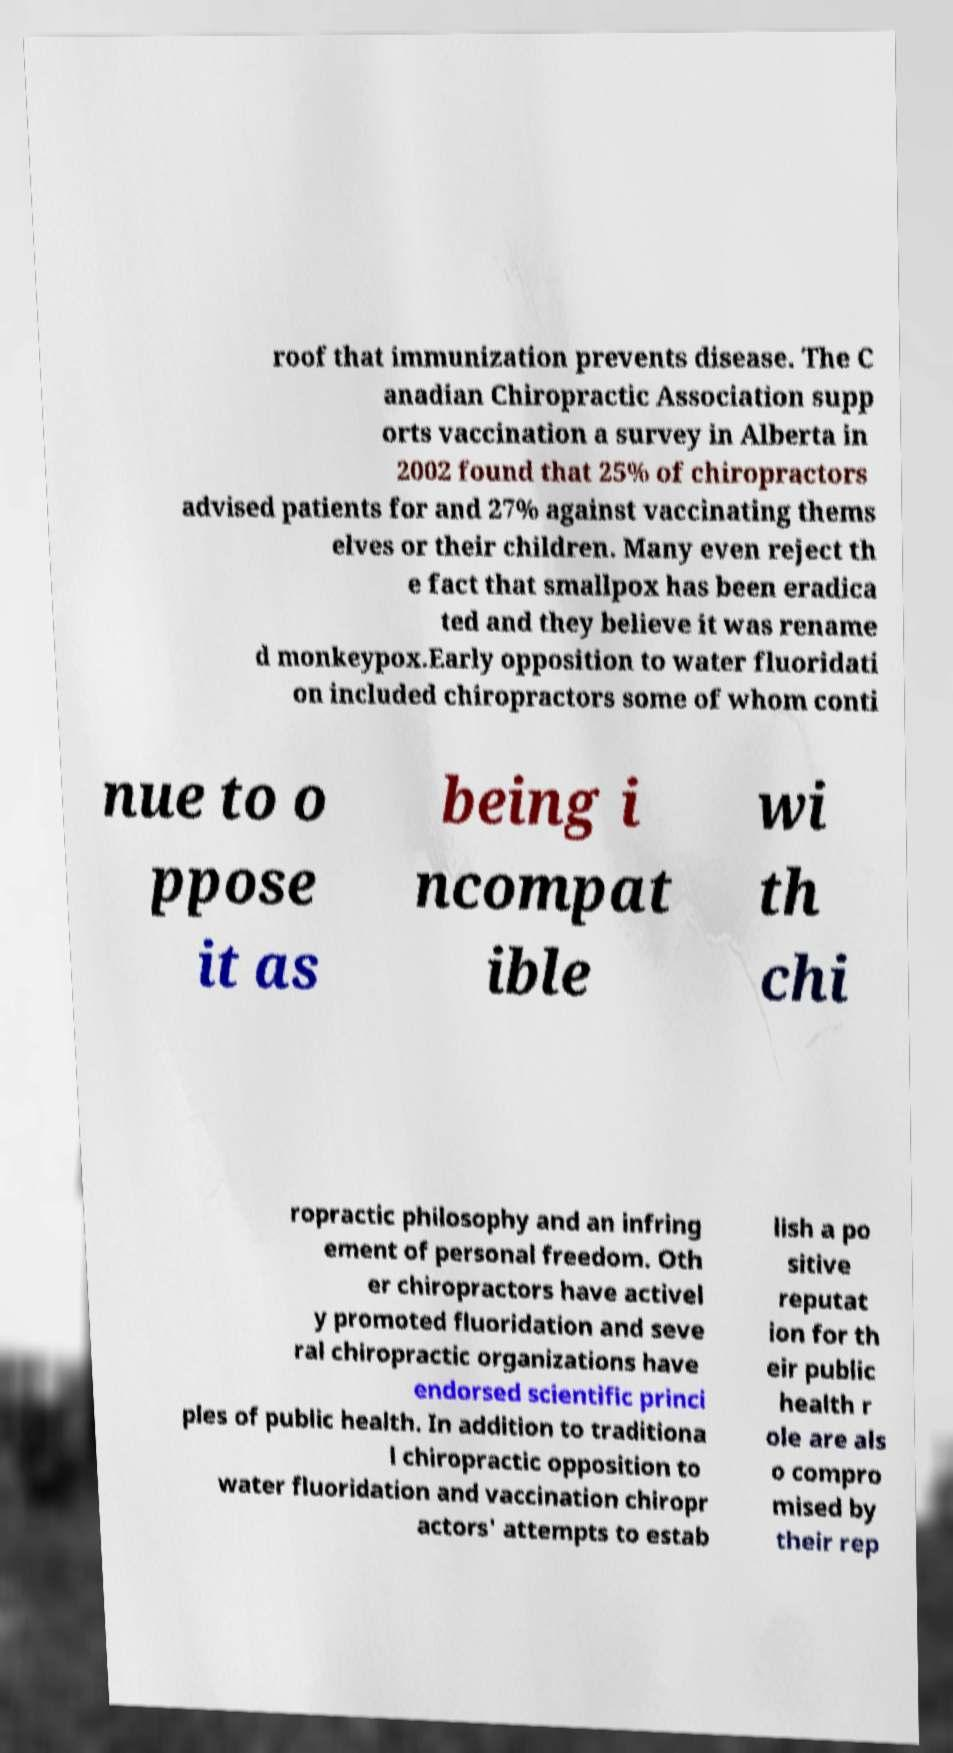I need the written content from this picture converted into text. Can you do that? roof that immunization prevents disease. The C anadian Chiropractic Association supp orts vaccination a survey in Alberta in 2002 found that 25% of chiropractors advised patients for and 27% against vaccinating thems elves or their children. Many even reject th e fact that smallpox has been eradica ted and they believe it was rename d monkeypox.Early opposition to water fluoridati on included chiropractors some of whom conti nue to o ppose it as being i ncompat ible wi th chi ropractic philosophy and an infring ement of personal freedom. Oth er chiropractors have activel y promoted fluoridation and seve ral chiropractic organizations have endorsed scientific princi ples of public health. In addition to traditiona l chiropractic opposition to water fluoridation and vaccination chiropr actors' attempts to estab lish a po sitive reputat ion for th eir public health r ole are als o compro mised by their rep 